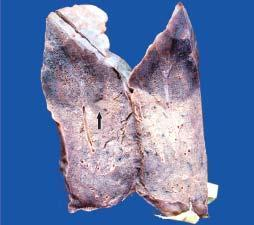what shows dark tan firm areas with base on the pleura?
Answer the question using a single word or phrase. The sectioned surface 